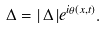<formula> <loc_0><loc_0><loc_500><loc_500>\Delta = | \, \Delta \, | e ^ { i \theta ( x , t ) } .</formula> 